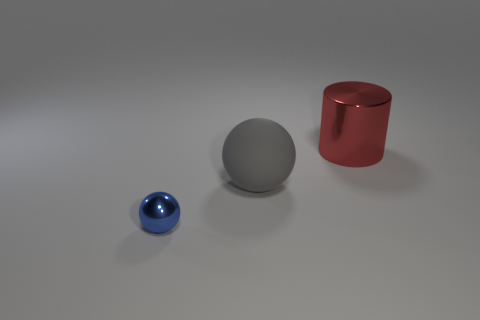If these objects were part of a still life painting, what mood might the artist be trying to convey? If these objects were part of a still life composition, the artist might be conveying a mood of serenity and balance. The minimalistic arrangement, subdued colors, and soft lighting create a tranquil and introspective atmosphere. It might suggest themes of simplicity, harmony, and the beauty found in everyday objects. 